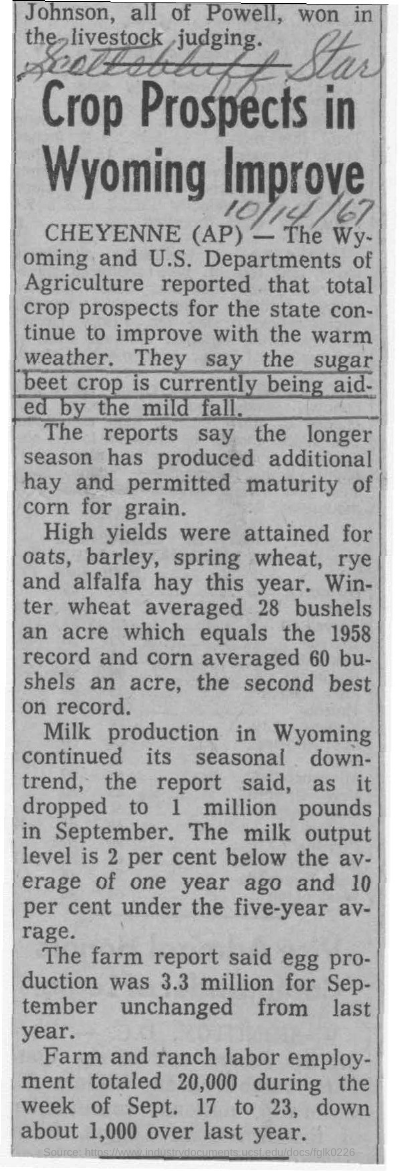Draw attention to some important aspects in this diagram. According to recent news, high yields have been achieved in crops such as oats, barley, spring wheat, rye, and alfalfa hay. The egg production for September, as stated in the farm report, was 3.3 million. Crop prospects in Wyoming have improved, according to recent news. In September of a certain year, milk production in Wyoming dropped to 1 million pounds. 